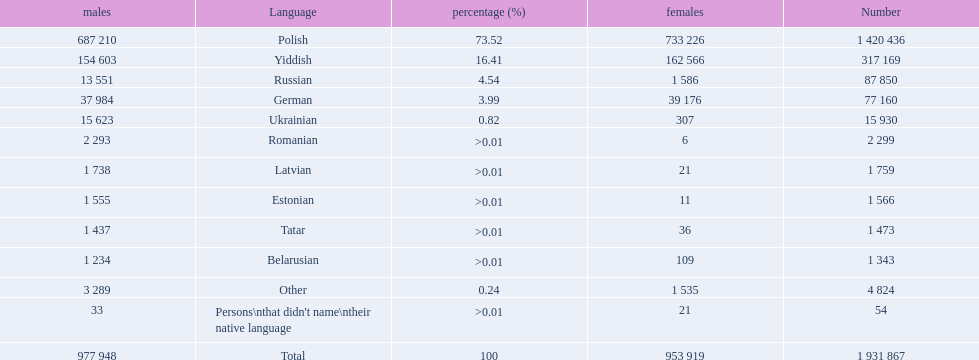What are the languages of the warsaw governorate? Polish, Yiddish, Russian, German, Ukrainian, Romanian, Latvian, Estonian, Tatar, Belarusian, Other. What is the percentage of polish? 73.52. What is the next highest amount? 16.41. What is the language with this amount? Yiddish. 